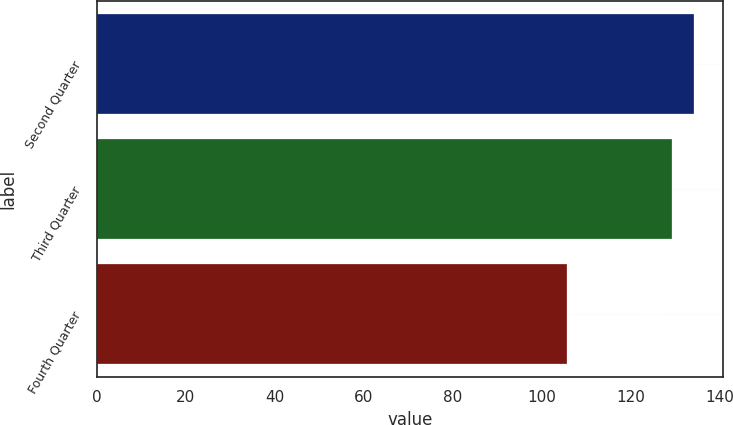<chart> <loc_0><loc_0><loc_500><loc_500><bar_chart><fcel>Second Quarter<fcel>Third Quarter<fcel>Fourth Quarter<nl><fcel>134.13<fcel>129.26<fcel>105.64<nl></chart> 